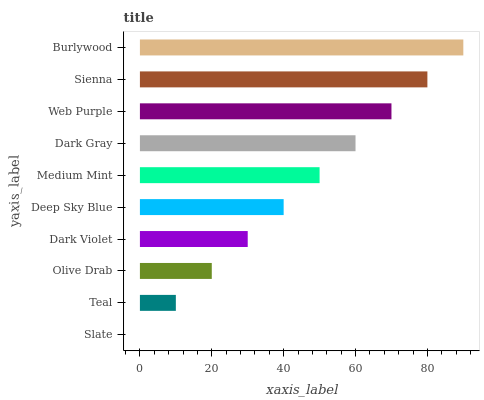Is Slate the minimum?
Answer yes or no. Yes. Is Burlywood the maximum?
Answer yes or no. Yes. Is Teal the minimum?
Answer yes or no. No. Is Teal the maximum?
Answer yes or no. No. Is Teal greater than Slate?
Answer yes or no. Yes. Is Slate less than Teal?
Answer yes or no. Yes. Is Slate greater than Teal?
Answer yes or no. No. Is Teal less than Slate?
Answer yes or no. No. Is Medium Mint the high median?
Answer yes or no. Yes. Is Deep Sky Blue the low median?
Answer yes or no. Yes. Is Slate the high median?
Answer yes or no. No. Is Olive Drab the low median?
Answer yes or no. No. 